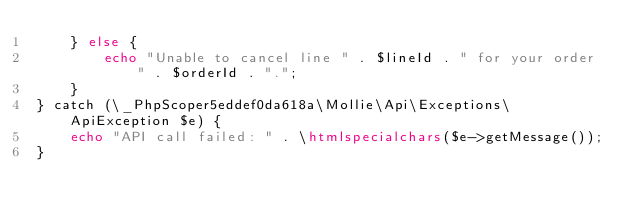Convert code to text. <code><loc_0><loc_0><loc_500><loc_500><_PHP_>    } else {
        echo "Unable to cancel line " . $lineId . " for your order " . $orderId . ".";
    }
} catch (\_PhpScoper5eddef0da618a\Mollie\Api\Exceptions\ApiException $e) {
    echo "API call failed: " . \htmlspecialchars($e->getMessage());
}
</code> 